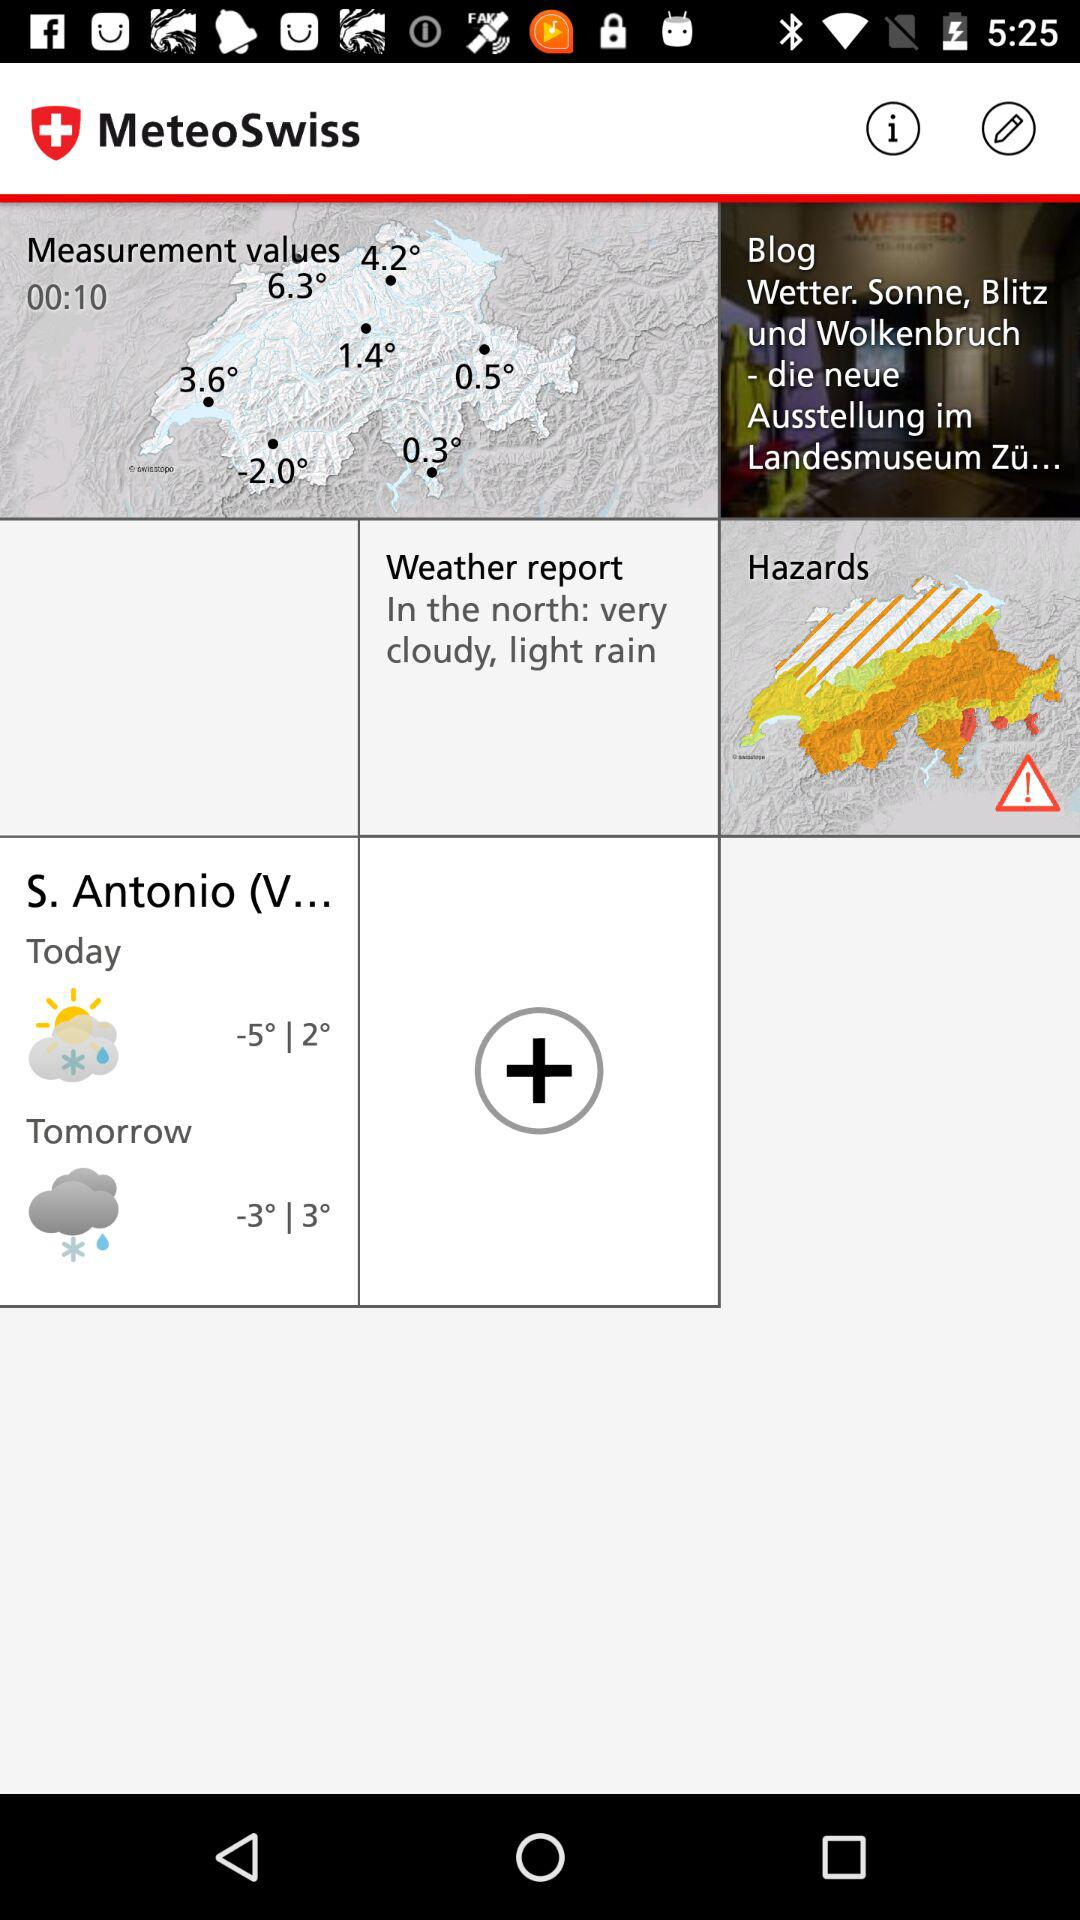What is the temperature for today? The temperature for today ranges from -5° to 2°. 